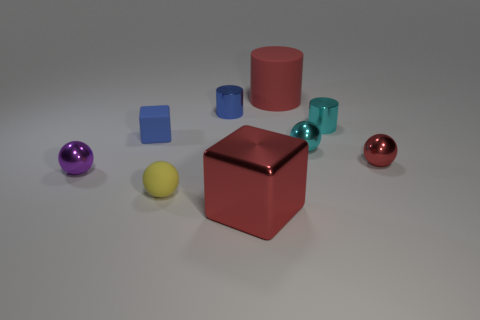Subtract all purple metal spheres. How many spheres are left? 3 Subtract 1 balls. How many balls are left? 3 Subtract all purple spheres. How many spheres are left? 3 Add 1 blocks. How many objects exist? 10 Subtract all brown spheres. Subtract all yellow cubes. How many spheres are left? 4 Subtract all cylinders. How many objects are left? 6 Add 1 large cylinders. How many large cylinders are left? 2 Add 5 small brown objects. How many small brown objects exist? 5 Subtract 0 green cubes. How many objects are left? 9 Subtract all cyan things. Subtract all small yellow matte spheres. How many objects are left? 6 